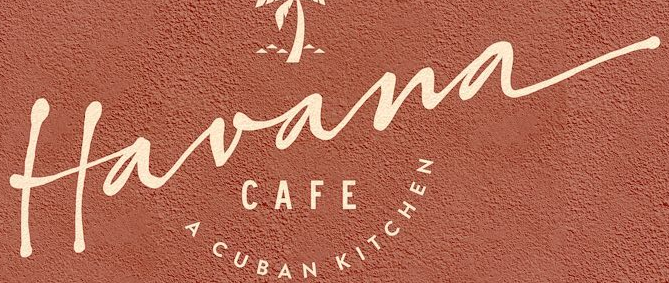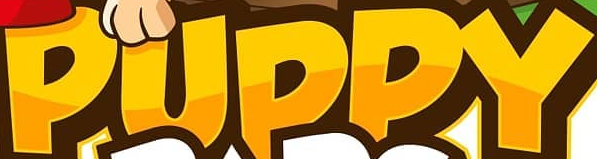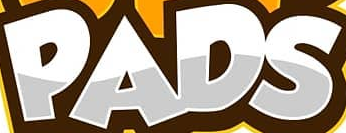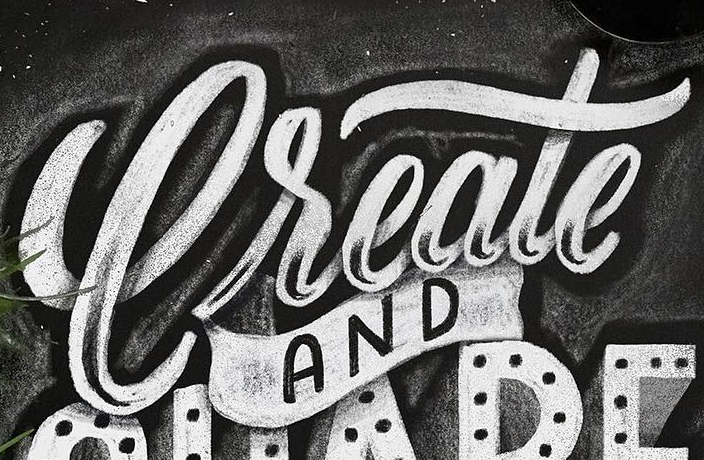Transcribe the words shown in these images in order, separated by a semicolon. Havana; PUPPY; PADS; Create 